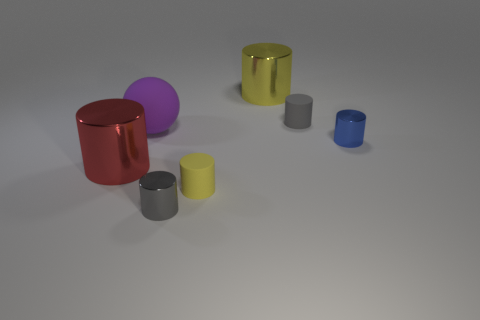Subtract all tiny rubber cylinders. How many cylinders are left? 4 Subtract all red cylinders. How many cylinders are left? 5 Subtract all cylinders. How many objects are left? 1 Subtract 2 cylinders. How many cylinders are left? 4 Subtract all green cylinders. Subtract all yellow cubes. How many cylinders are left? 6 Subtract all cyan cubes. How many gray cylinders are left? 2 Subtract all tiny green shiny spheres. Subtract all gray metal things. How many objects are left? 6 Add 5 rubber cylinders. How many rubber cylinders are left? 7 Add 5 yellow cylinders. How many yellow cylinders exist? 7 Add 2 big yellow objects. How many objects exist? 9 